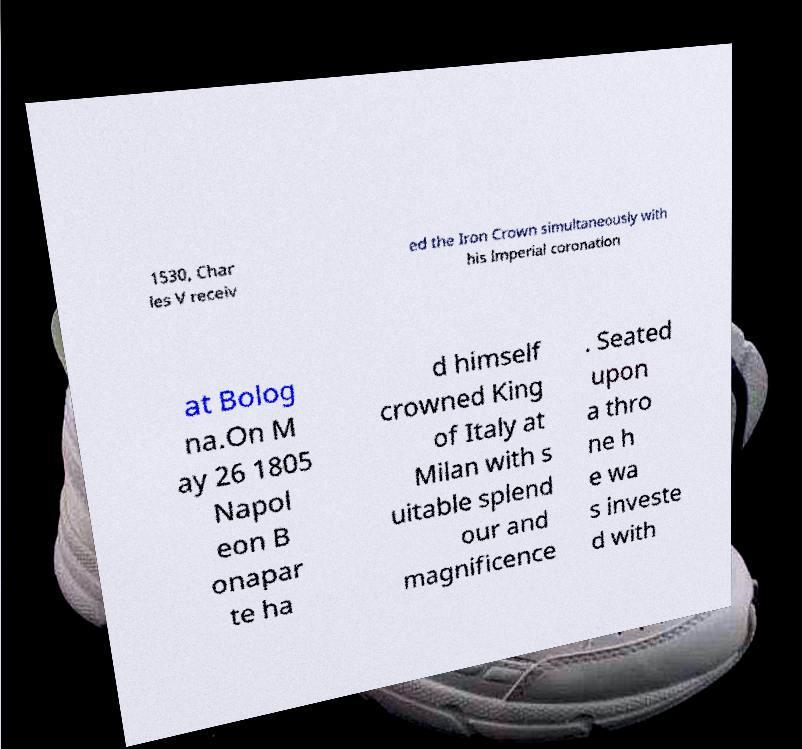Could you assist in decoding the text presented in this image and type it out clearly? 1530, Char les V receiv ed the Iron Crown simultaneously with his Imperial coronation at Bolog na.On M ay 26 1805 Napol eon B onapar te ha d himself crowned King of Italy at Milan with s uitable splend our and magnificence . Seated upon a thro ne h e wa s investe d with 